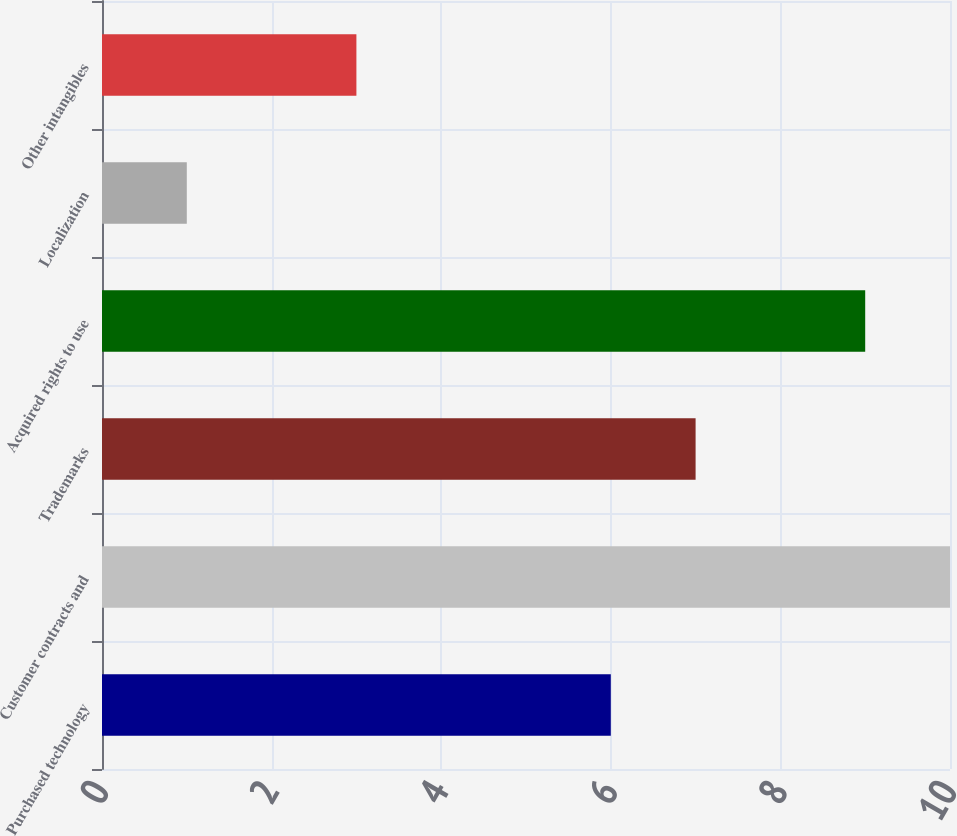Convert chart. <chart><loc_0><loc_0><loc_500><loc_500><bar_chart><fcel>Purchased technology<fcel>Customer contracts and<fcel>Trademarks<fcel>Acquired rights to use<fcel>Localization<fcel>Other intangibles<nl><fcel>6<fcel>10<fcel>7<fcel>9<fcel>1<fcel>3<nl></chart> 